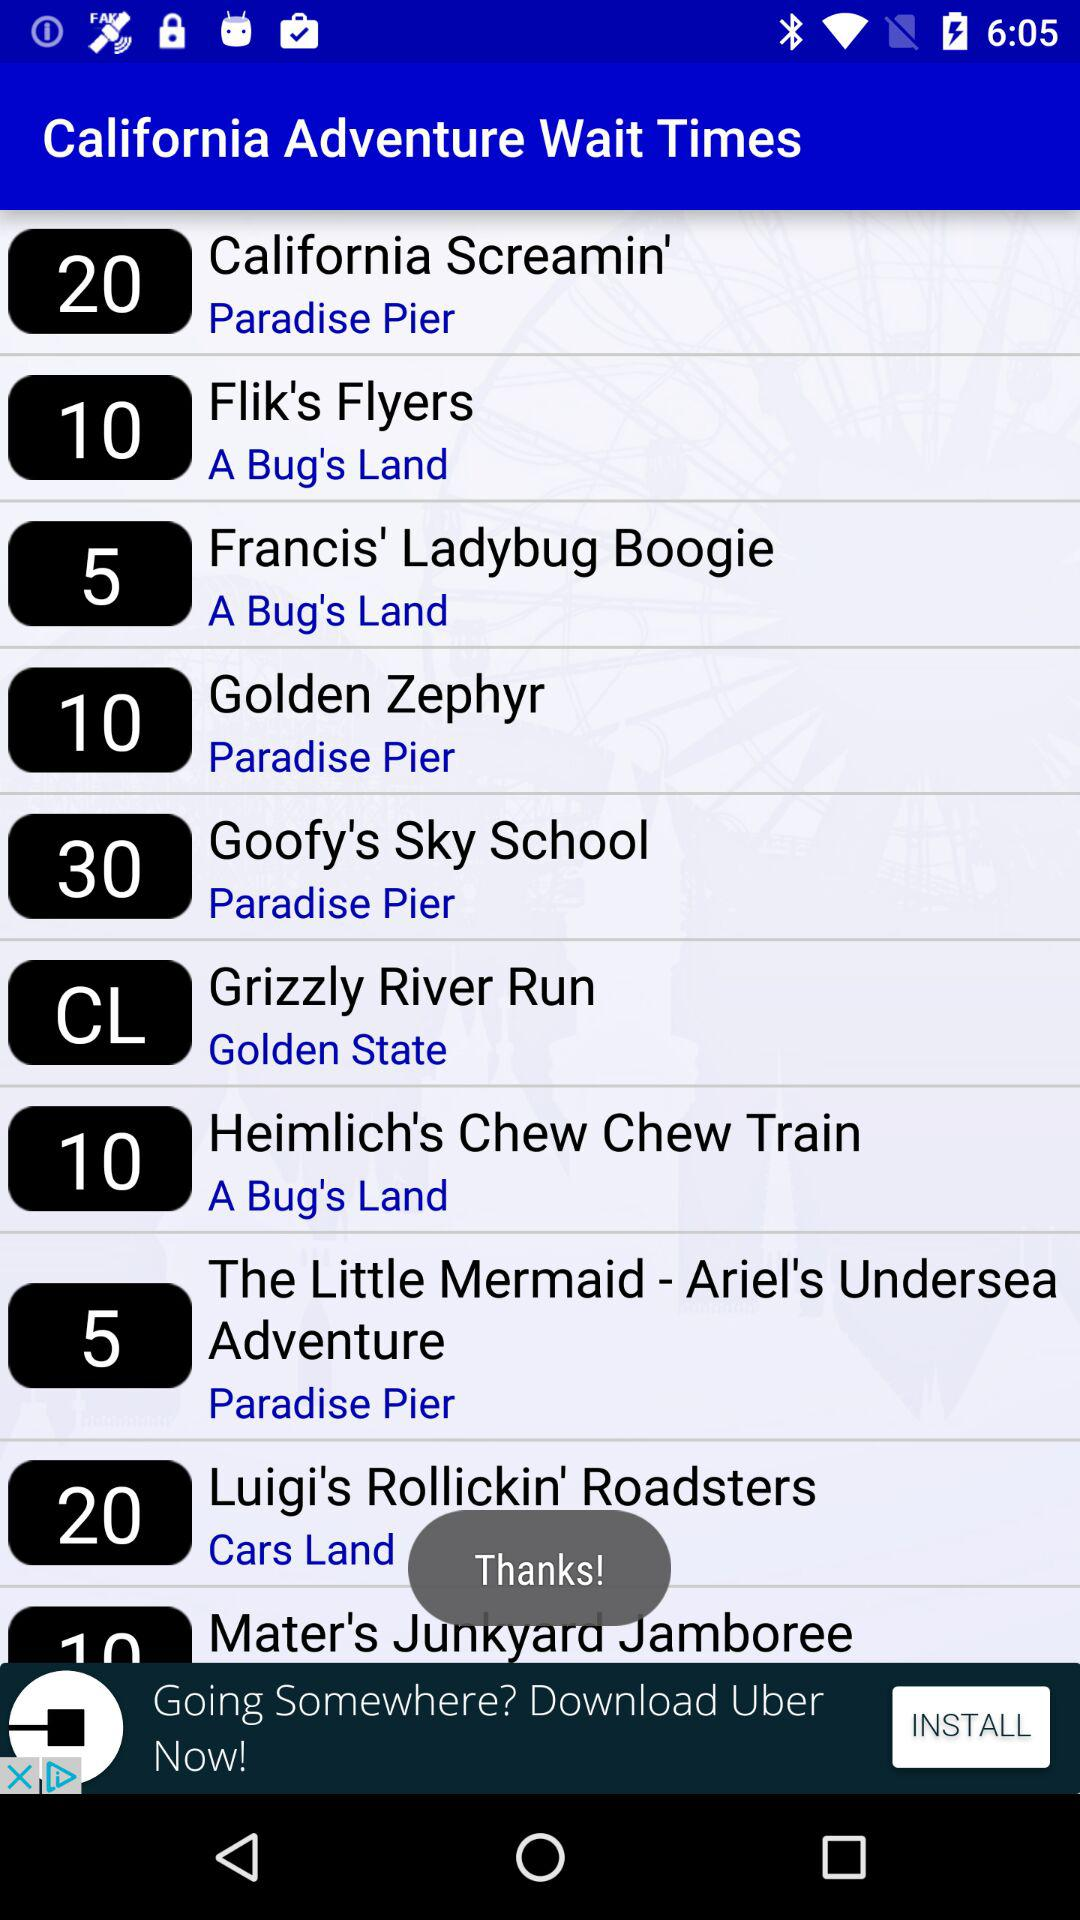What is the wait time for the Golden Zephyr?
When the provided information is insufficient, respond with <no answer>. <no answer> 